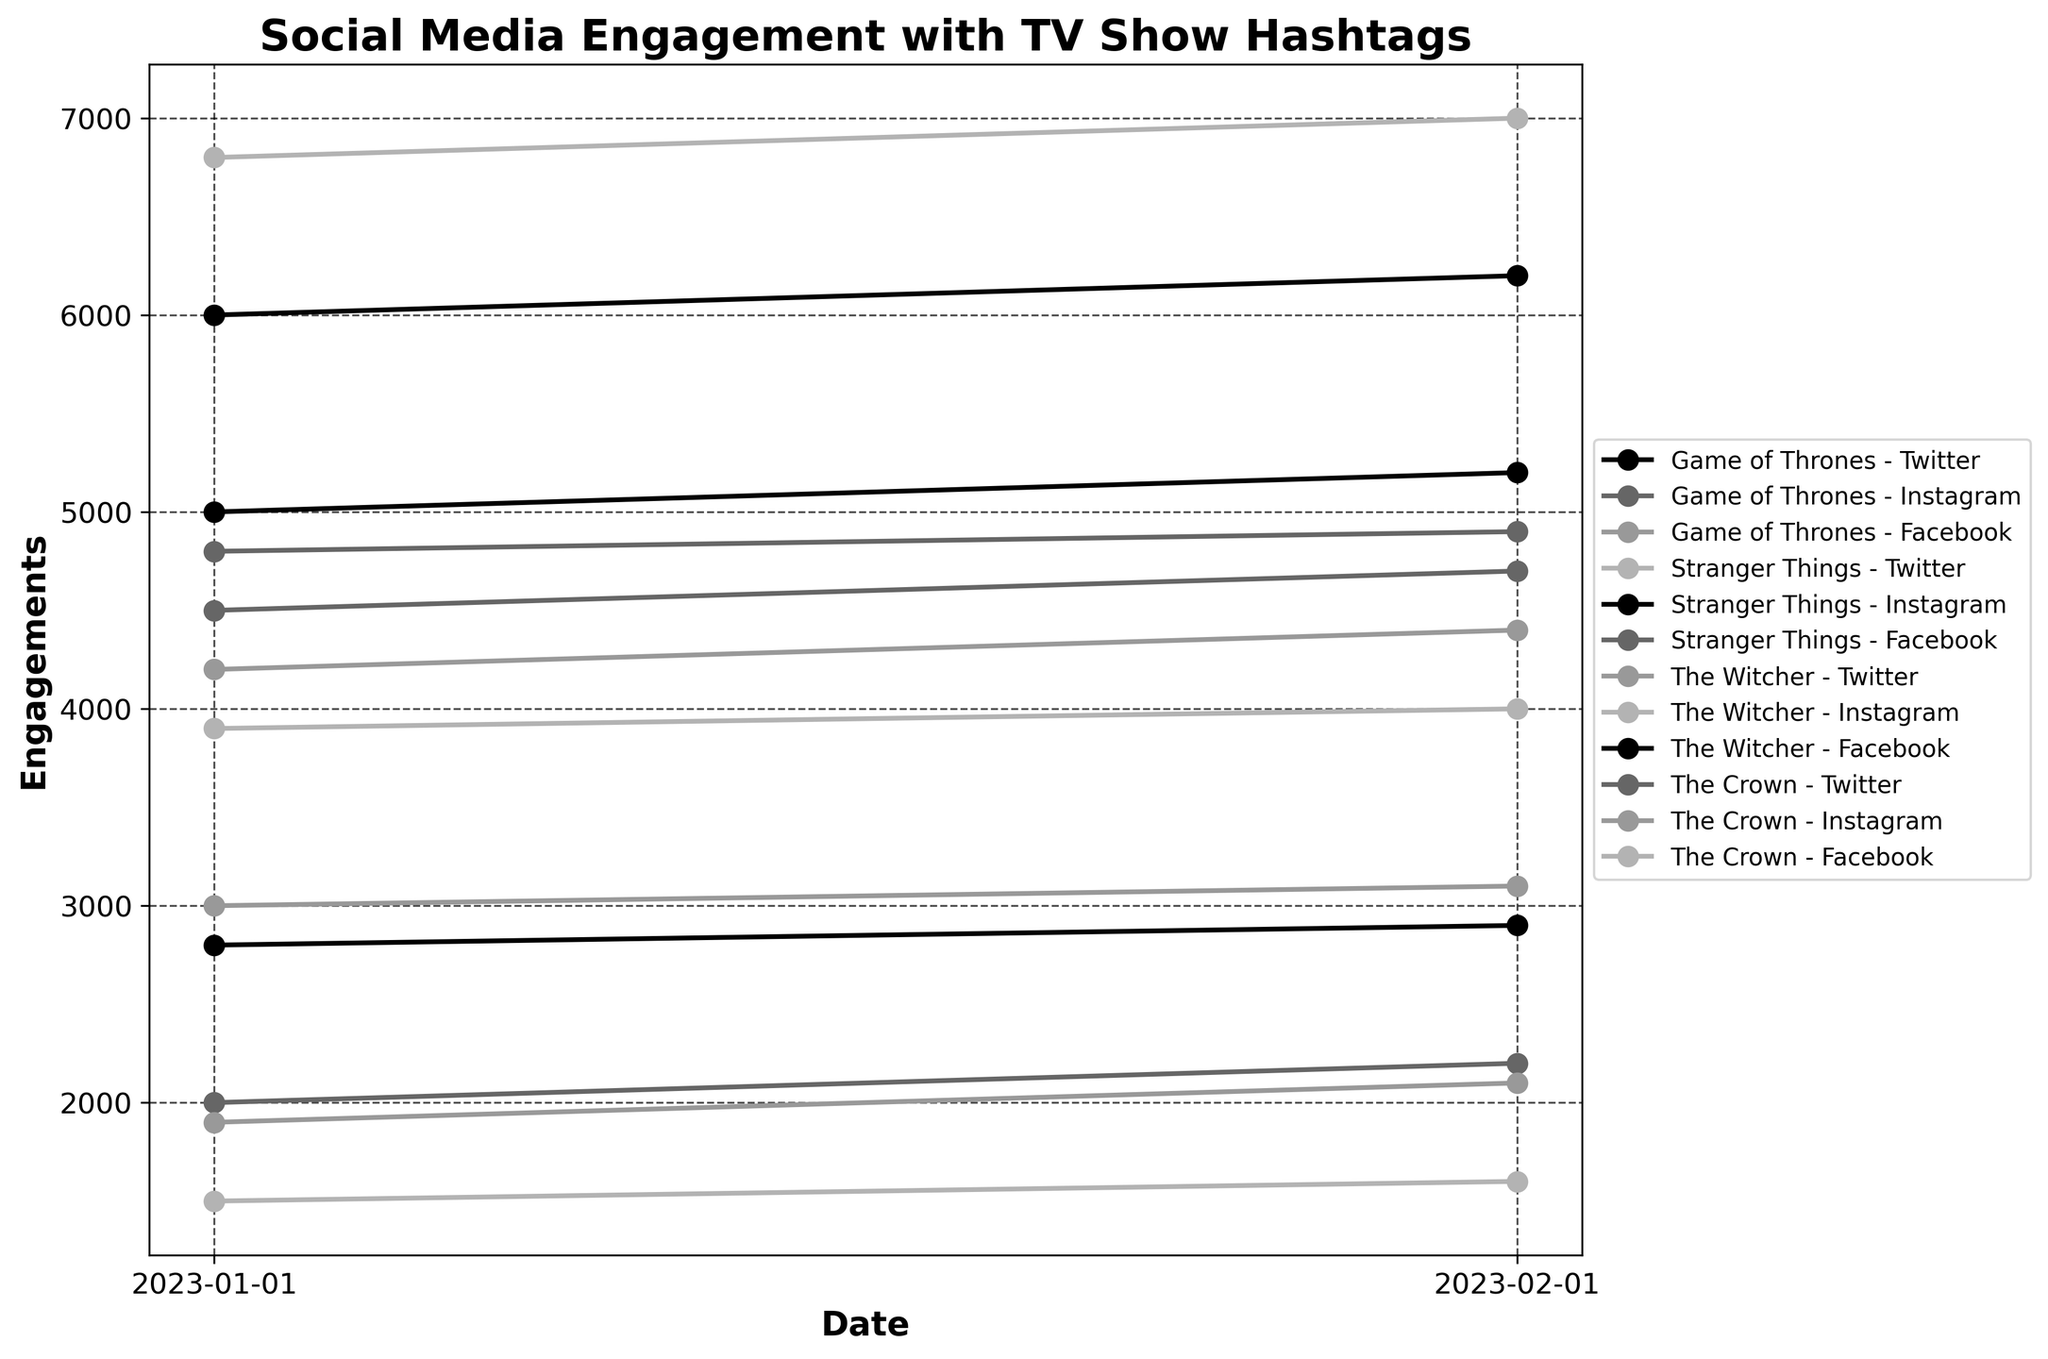What is the title of the plot? The title of the plot is located at the top center, and it reads "Social Media Engagement with TV Show Hashtags".
Answer: Social Media Engagement with TV Show Hashtags What are the labels of the x and y axes? The x-axis label can be seen at the bottom and reads "Date", while the y-axis label can be seen on the left side and reads "Engagements".
Answer: Date, Engagements Which TV show has the highest engagement on Twitter on 2023-02-01? Look at the points marked on 2023-02-01 for Twitter's engagement and compare their values. The highest value belongs to "Stranger Things" with 7000 engagements.
Answer: Stranger Things What is the total engagement for Facebook across all TV shows on 2023-01-01? Add up the engagements for all TV shows on Facebook on 2023-01-01: 3000 (Game of Thrones) + 4800 (Stranger Things) + 2800 (The Witcher) + 1500 (The Crown) = 12100 engagements.
Answer: 12100 Which platform shows the greatest increase in engagements for "The Crown" from 2023-01-01 to 2023-02-01? Compare the engagement values for "The Crown" on each platform between 2023-01-01 and 2023-02-01. Instagram shows the greatest increase, going from 1900 to 2100, an increase of 200.
Answer: Instagram What's the average engagement for "Game of Thrones" on Instagram across the two dates? The engagement values for "Game of Thrones" on Instagram are 4500 on 2023-01-01 and 4700 on 2023-02-01. The average is calculated as (4500 + 4700) / 2 = 4600.
Answer: 4600 Which two platforms typically have the closest engagement values for "The Witcher"? Look at the engagement values for "The Witcher" across all platforms. Twitter and Instagram have engagements of 4200 and 3900 on 2023-01-01, and 4400 and 4000 on 2023-02-01. These values are closest on both dates.
Answer: Twitter and Instagram During the given period, which TV show has the least stable engagement on all platforms combined? The stability can be evaluated by comparing the fluctuations in engagement values across both dates for all shows. "The Crown" shows more dramatic relative engagements fluctuations compared to others.
Answer: The Crown 